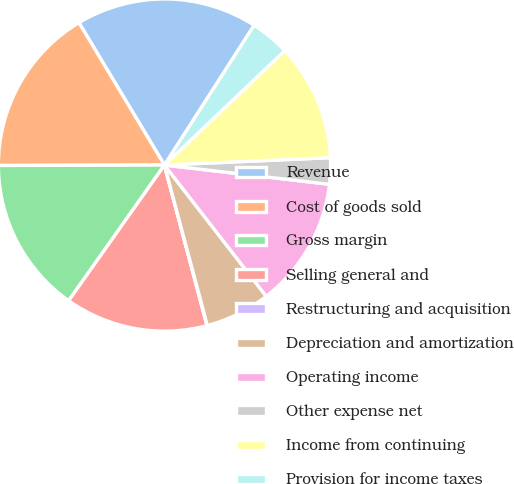<chart> <loc_0><loc_0><loc_500><loc_500><pie_chart><fcel>Revenue<fcel>Cost of goods sold<fcel>Gross margin<fcel>Selling general and<fcel>Restructuring and acquisition<fcel>Depreciation and amortization<fcel>Operating income<fcel>Other expense net<fcel>Income from continuing<fcel>Provision for income taxes<nl><fcel>17.69%<fcel>16.43%<fcel>15.17%<fcel>13.91%<fcel>0.04%<fcel>6.34%<fcel>12.65%<fcel>2.56%<fcel>11.39%<fcel>3.82%<nl></chart> 